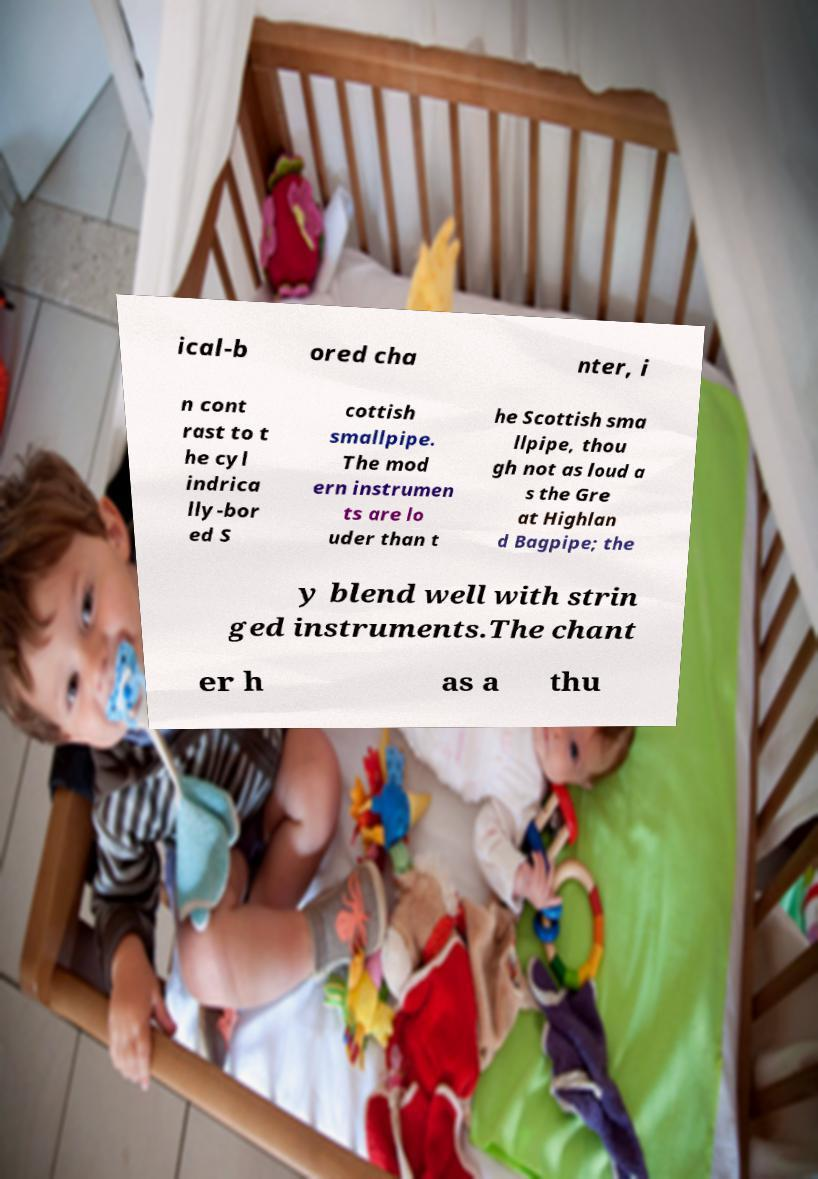I need the written content from this picture converted into text. Can you do that? ical-b ored cha nter, i n cont rast to t he cyl indrica lly-bor ed S cottish smallpipe. The mod ern instrumen ts are lo uder than t he Scottish sma llpipe, thou gh not as loud a s the Gre at Highlan d Bagpipe; the y blend well with strin ged instruments.The chant er h as a thu 